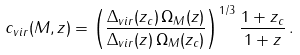Convert formula to latex. <formula><loc_0><loc_0><loc_500><loc_500>c _ { v i r } ( M , z ) = \left ( \frac { \Delta _ { v i r } ( z _ { c } ) \, \Omega _ { M } ( z ) } { \Delta _ { v i r } ( z ) \, \Omega _ { M } ( z _ { c } ) } \right ) ^ { 1 / 3 } \frac { 1 + z _ { c } } { 1 + z } \, .</formula> 